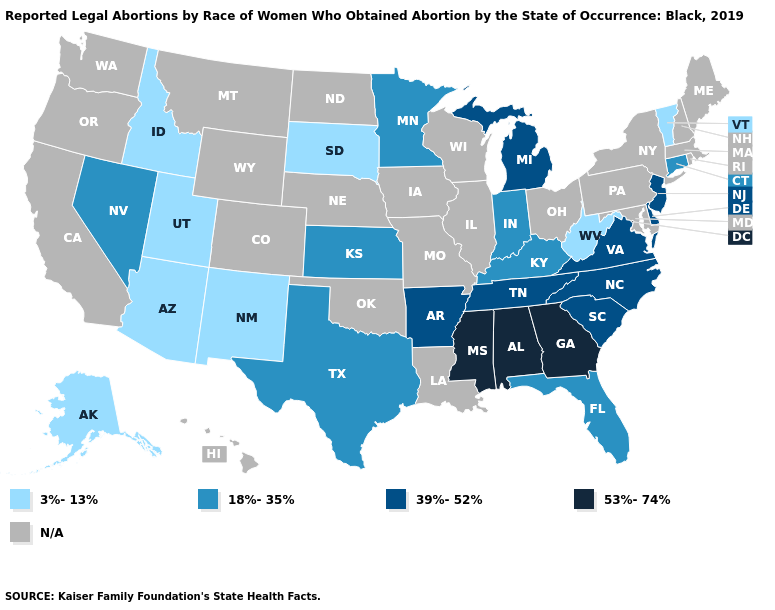Which states hav the highest value in the MidWest?
Keep it brief. Michigan. Among the states that border Virginia , does North Carolina have the lowest value?
Give a very brief answer. No. Name the states that have a value in the range N/A?
Concise answer only. California, Colorado, Hawaii, Illinois, Iowa, Louisiana, Maine, Maryland, Massachusetts, Missouri, Montana, Nebraska, New Hampshire, New York, North Dakota, Ohio, Oklahoma, Oregon, Pennsylvania, Rhode Island, Washington, Wisconsin, Wyoming. What is the value of Montana?
Answer briefly. N/A. Among the states that border Nebraska , does South Dakota have the lowest value?
Be succinct. Yes. What is the value of South Carolina?
Answer briefly. 39%-52%. Does the first symbol in the legend represent the smallest category?
Give a very brief answer. Yes. Is the legend a continuous bar?
Write a very short answer. No. What is the value of Indiana?
Write a very short answer. 18%-35%. What is the highest value in the Northeast ?
Keep it brief. 39%-52%. Which states have the lowest value in the USA?
Short answer required. Alaska, Arizona, Idaho, New Mexico, South Dakota, Utah, Vermont, West Virginia. How many symbols are there in the legend?
Be succinct. 5. What is the lowest value in states that border Washington?
Answer briefly. 3%-13%. Name the states that have a value in the range 18%-35%?
Concise answer only. Connecticut, Florida, Indiana, Kansas, Kentucky, Minnesota, Nevada, Texas. What is the value of New Jersey?
Quick response, please. 39%-52%. 